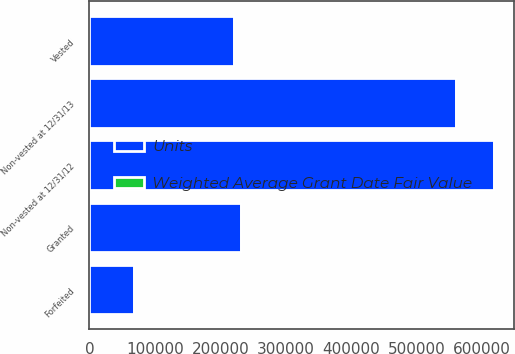Convert chart to OTSL. <chart><loc_0><loc_0><loc_500><loc_500><stacked_bar_chart><ecel><fcel>Non-vested at 12/31/12<fcel>Granted<fcel>Vested<fcel>Forfeited<fcel>Non-vested at 12/31/13<nl><fcel>Units<fcel>618910<fcel>231435<fcel>221695<fcel>67851<fcel>560799<nl><fcel>Weighted Average Grant Date Fair Value<fcel>44.66<fcel>55.12<fcel>41.34<fcel>52.67<fcel>49.32<nl></chart> 